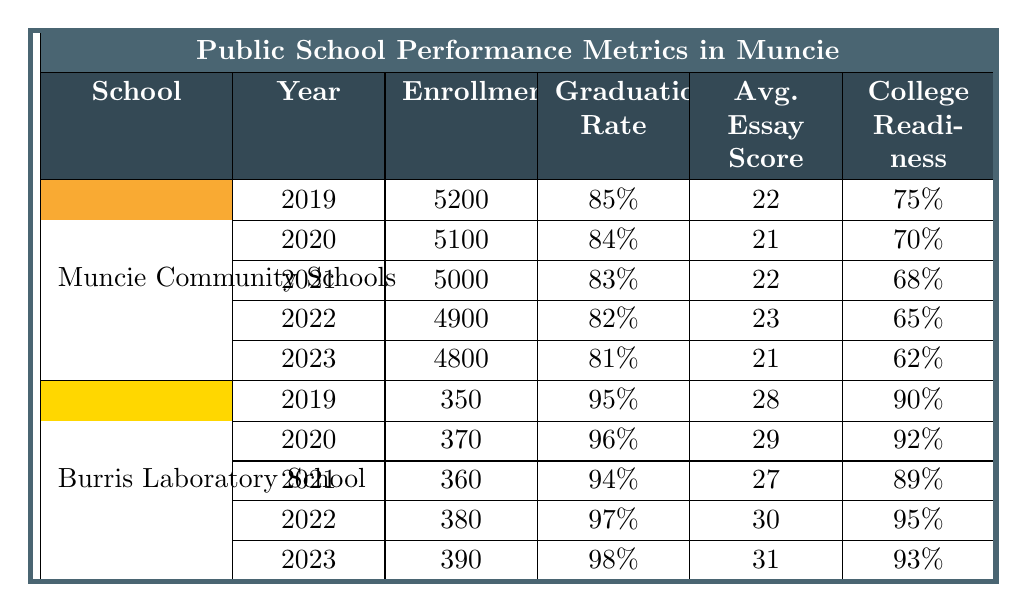What was the enrollment in Muncie Community Schools in 2021? Referring to the row for Muncie Community Schools in 2021, the enrollment is listed as 5000.
Answer: 5000 What is the highest graduation rate recorded in Burris Laboratory School over the last five years? Looking at the graduation rates for Burris Laboratory School, the highest rate is 98% in 2023.
Answer: 98% What was the average essay score for Muncie Community Schools in 2022 compared to 2023? In 2022, the average essay score was 23, while in 2023 it decreased to 21. The difference is 23 - 21 = 2.
Answer: 2 Did Muncie Community Schools see an increase or decrease in college readiness from 2019 to 2023? In 2019, college readiness was 75%, and in 2023, it dropped to 62%. This shows a decrease.
Answer: Decrease What was the total enrollment for both schools combined in 2020? The enrollment in Muncie Community Schools in 2020 was 5100 and in Burris Laboratory School it was 370. Adding these gives 5100 + 370 = 5470.
Answer: 5470 Which school had a higher average essay score in 2021? Muncie Community Schools had an average essay score of 22, and Burris Laboratory School had 27. Since 27 is greater than 22, Burris had a higher score.
Answer: Burris Laboratory School What is the trend in college readiness for Muncie Community Schools over the last five years? The college readiness percentages for Muncie Community Schools have gone from 75% in 2019 to 62% in 2023, showing a consistent downward trend.
Answer: Downward trend How much did the Math score change in the National Assessment from 2019 to 2023 for Muncie Community Schools? The Math score in 2019 was 45%, and by 2023 it fell to 39%. The change is 45% - 39% = 6%.
Answer: 6% In what year did Burris Laboratory School first achieve a graduation rate of 97% or higher? Burris Laboratory School reached a graduation rate of 97% in 2022, meeting the criteria for the first time in that year.
Answer: 2022 Was the average essay score higher in Burris Laboratory School than Muncie Community Schools in 2020? Burris Laboratory School had an average essay score of 29 in 2020, while Muncie Community Schools had 21. Therefore, Burris scored higher.
Answer: Yes What is the overall change in enrollment for Muncie Community Schools from 2019 to 2023? Enrollment was 5200 in 2019 and dropped to 4800 in 2023, resulting in a change of 5200 - 4800 = 400.
Answer: 400 decrease 